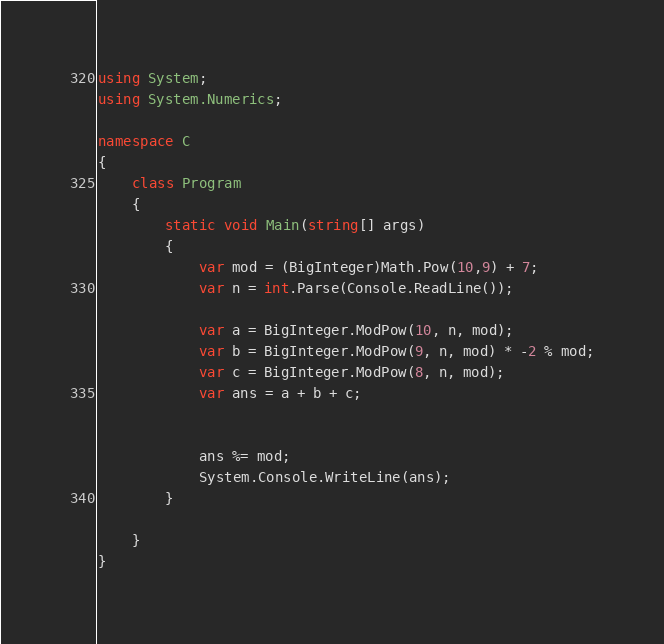Convert code to text. <code><loc_0><loc_0><loc_500><loc_500><_C#_>using System;
using System.Numerics;

namespace C
{
    class Program
    {
        static void Main(string[] args)
        {
            var mod = (BigInteger)Math.Pow(10,9) + 7;
            var n = int.Parse(Console.ReadLine());

            var a = BigInteger.ModPow(10, n, mod);
            var b = BigInteger.ModPow(9, n, mod) * -2 % mod;
            var c = BigInteger.ModPow(8, n, mod);
            var ans = a + b + c;

            
            ans %= mod;
            System.Console.WriteLine(ans);
        }

    }
}</code> 